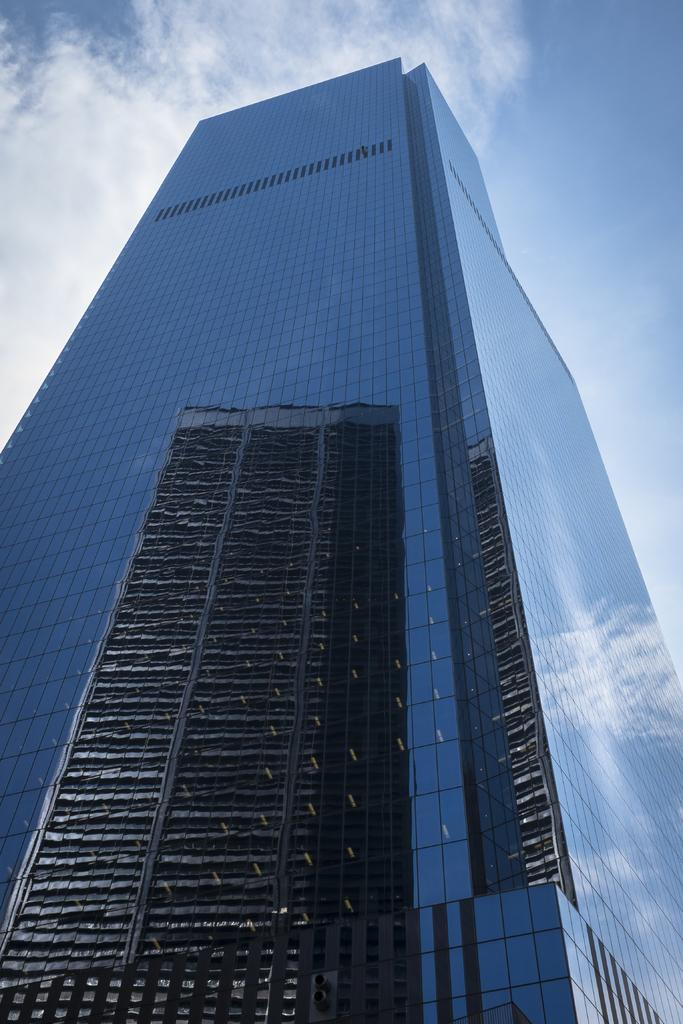What type of building is in the image? There is a skyscraper in the image. What can be seen in the background of the image? The sky is visible in the image. What is the condition of the sky in the image? Clouds are present in the sky. What type of picture is hanging on the wall in the image? There is no picture hanging on the wall in the image; it only features a skyscraper and the sky. What architectural feature can be seen in the image? There is no specific architectural feature mentioned in the provided facts, only the presence of a skyscraper. 